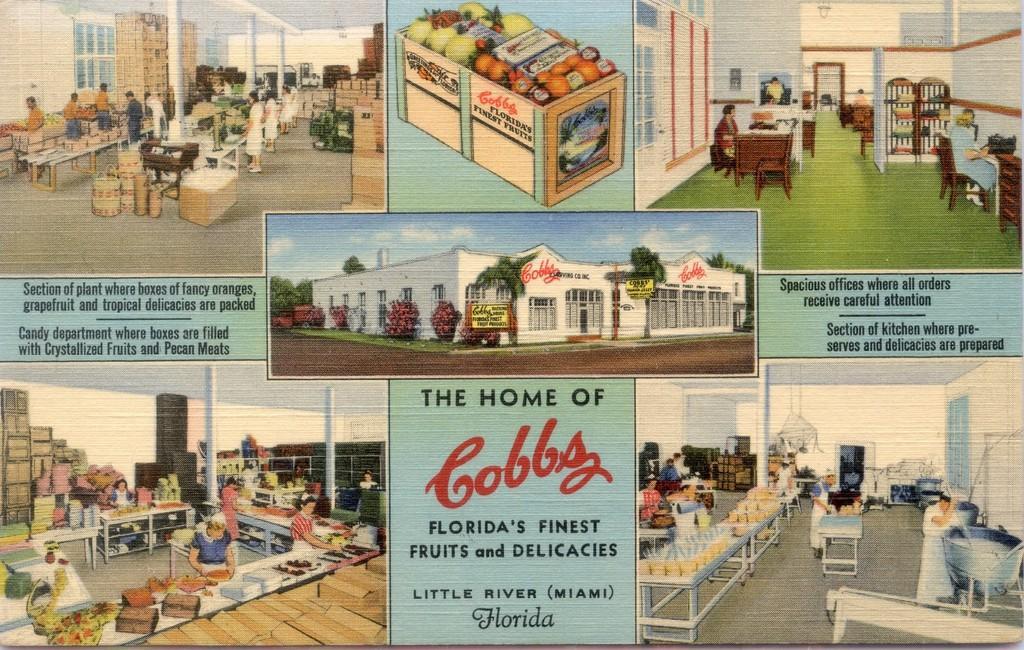Please provide a concise description of this image. In this picture we can see a building, trees, name boards, box with fruits in it, tables, windows, some objects, sky with clouds, group of people and some text. 